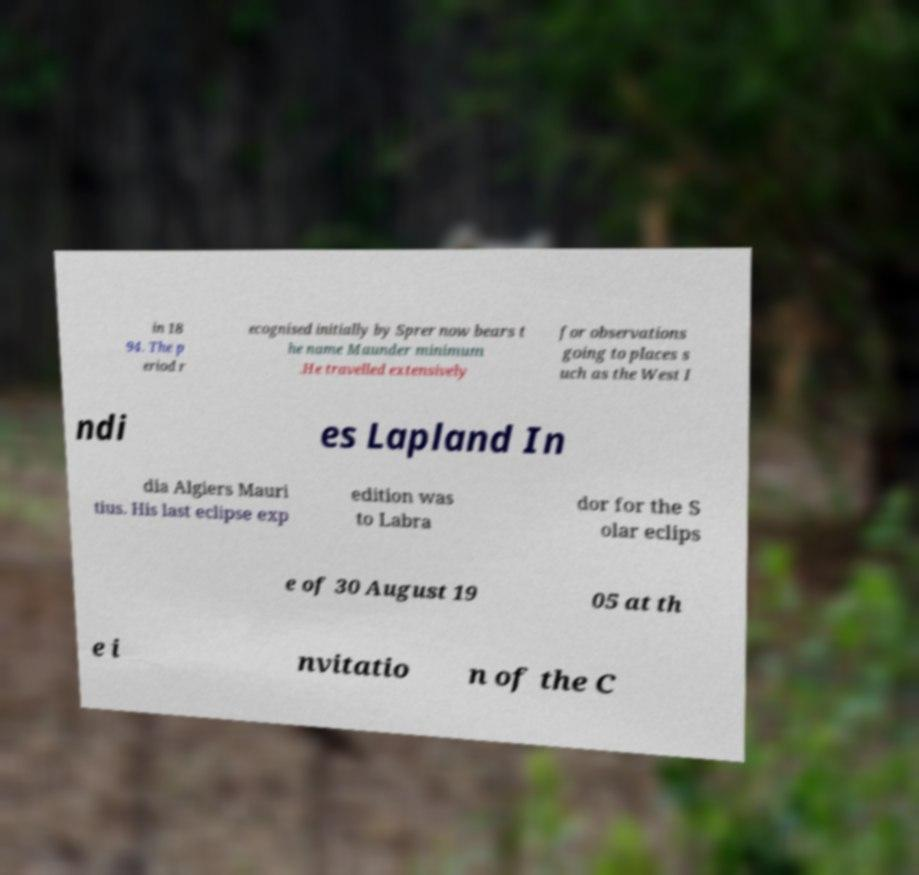Can you read and provide the text displayed in the image?This photo seems to have some interesting text. Can you extract and type it out for me? in 18 94. The p eriod r ecognised initially by Sprer now bears t he name Maunder minimum .He travelled extensively for observations going to places s uch as the West I ndi es Lapland In dia Algiers Mauri tius. His last eclipse exp edition was to Labra dor for the S olar eclips e of 30 August 19 05 at th e i nvitatio n of the C 